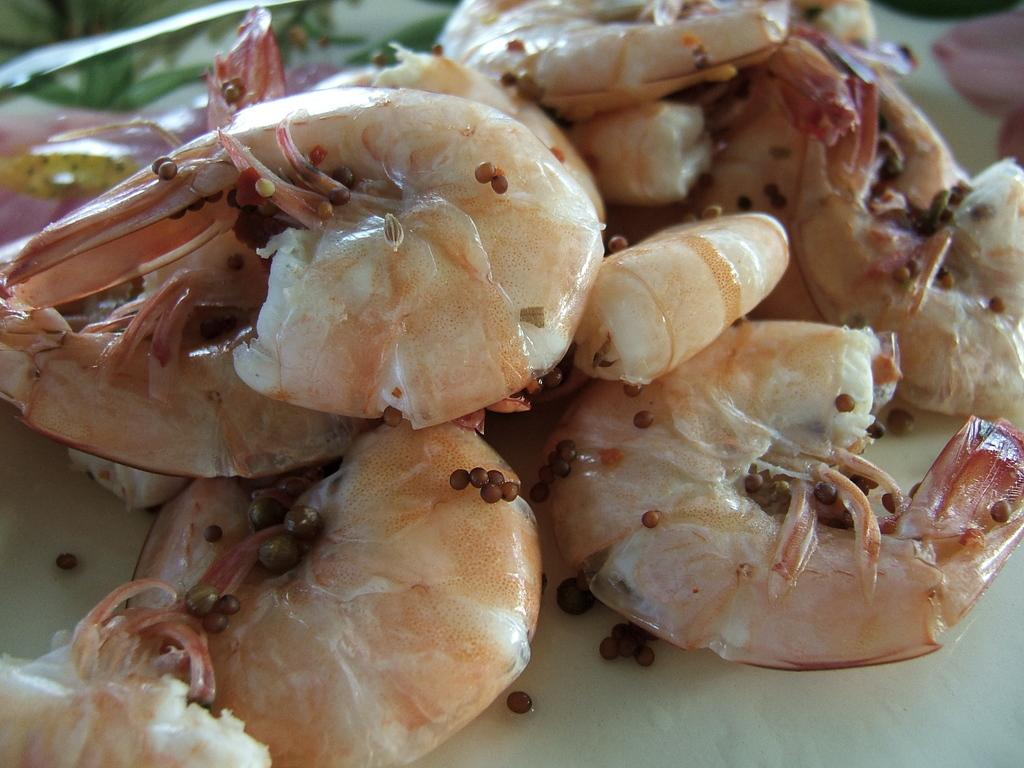What is the main subject of the image? The main subject of the image is food items in the center. Can you identify any specific food items in the image? Yes, the food items appear to include prawns. Are there any other food items visible in the image? Yes, there are other food items in the image. What can be seen in the background of the image? There are objects visible in the background of the image. What year is depicted in the image? There is no year depicted in the image; it is a still image of food items. Can you see a horn in the image? No, there is no horn present in the image. 